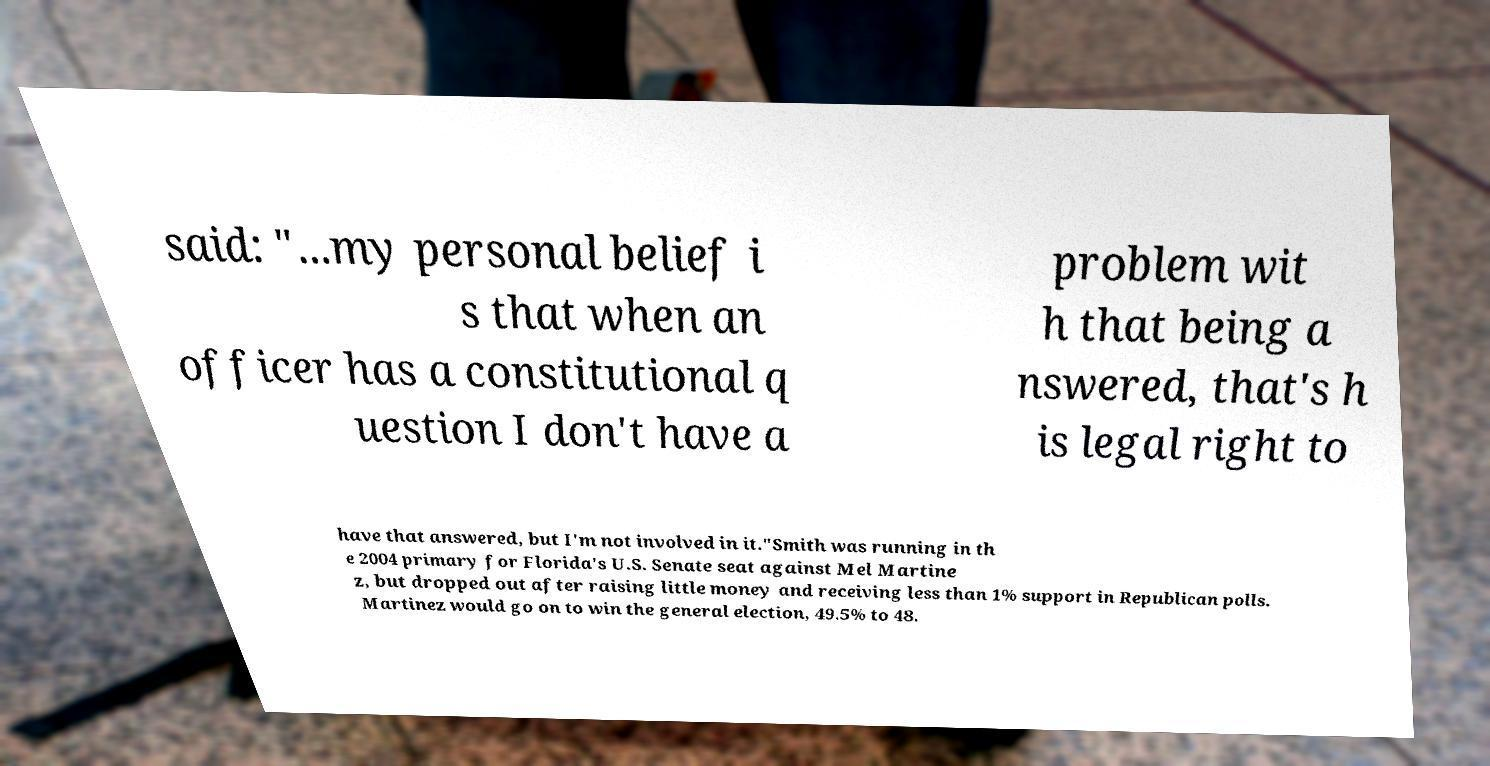There's text embedded in this image that I need extracted. Can you transcribe it verbatim? said: "...my personal belief i s that when an officer has a constitutional q uestion I don't have a problem wit h that being a nswered, that's h is legal right to have that answered, but I'm not involved in it."Smith was running in th e 2004 primary for Florida's U.S. Senate seat against Mel Martine z, but dropped out after raising little money and receiving less than 1% support in Republican polls. Martinez would go on to win the general election, 49.5% to 48. 